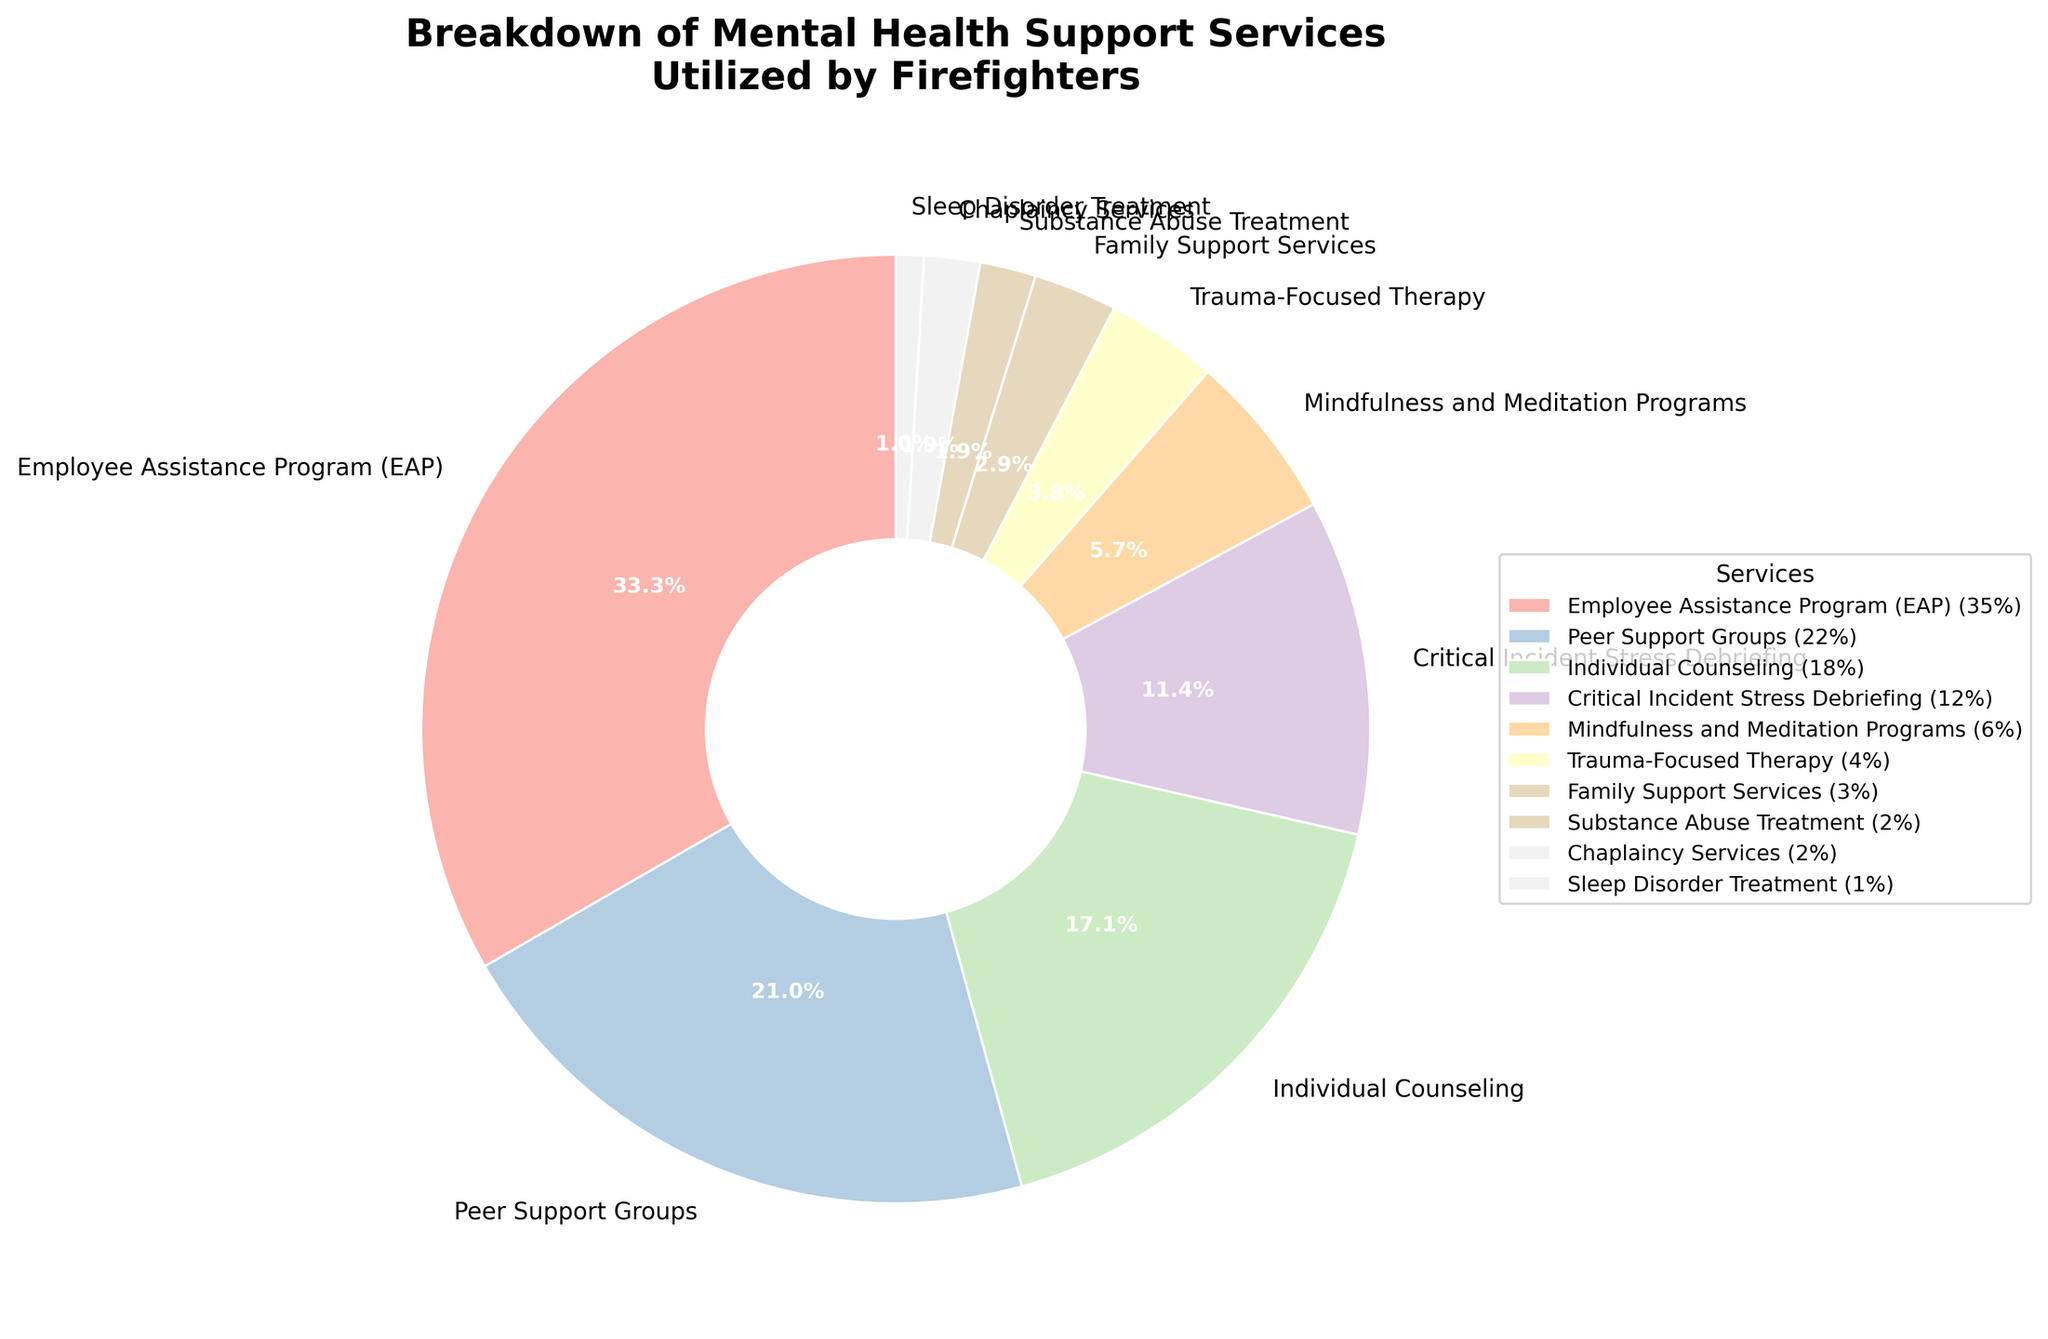What service is utilized by the highest percentage of firefighters? The pie chart shows the percentages of each mental health support service utilized by firefighters. The Employee Assistance Program (EAP) has the largest segment, which is 35%.
Answer: Employee Assistance Program (EAP) Which service category occupies the least proportion of the pie chart? The pie chart has several categories with small proportions, but Sleep Disorder Treatment has the smallest segment, which is 1%.
Answer: Sleep Disorder Treatment How much more percentage points does Peer Support Groups have compared to Family Support Services? Peer Support Groups is at 22%, and Family Support Services is at 3%. Subtract the percentage of Family Support Services from Peer Support Groups: 22% - 3% = 19%.
Answer: 19% What is the combined percentage of services that have single-digit representation? The services with single-digit percentages are: Mindfulness and Meditation Programs (6%), Trauma-Focused Therapy (4%), Family Support Services (3%), Substance Abuse Treatment (2%), Chaplaincy Services (2%), and Sleep Disorder Treatment (1%). Adding these together: 6% + 4% + 3% + 2% + 2% + 1% = 18%.
Answer: 18% Which two services combined equal the usage percentage of Employee Assistance Program (EAP)? The EAP accounts for 35%. The two services Peer Support Groups (22%) and Individual Counseling (18%) together add up to 40%, which is higher. So, we should consider another pair: Individual Counseling (18%) and Critical Incident Stress Debriefing (12%) sum to 30%, which is also lower. When we combine Peer Support Groups (22%) and Critical Incident Stress Debriefing (12%), it results in 34%, which is closest but not exact. Therefore, the exact pair is not directly visible; a potential error in the chart or data might be there.
Answer: None Which service accounts for 6% of the total usage? The pie chart segment labeled "Mindfulness and Meditation Programs" represents 6% of the total usage.
Answer: Mindfulness and Meditation Programs What is the total percentage of services that specifically address critical incidents? The services directly addressing critical incidents are Critical Incident Stress Debriefing (12%) and Trauma-Focused Therapy (4%). Adding these together: 12% + 4% = 16%.
Answer: 16% By how many percentage points does the Employee Assistance Program (EAP) exceed Individual Counseling? The Employee Assistance Program (EAP) is at 35% and Individual Counseling is at 18%. Subtract the percentage of Individual Counseling from EAP: 35% - 18% = 17%.
Answer: 17% 